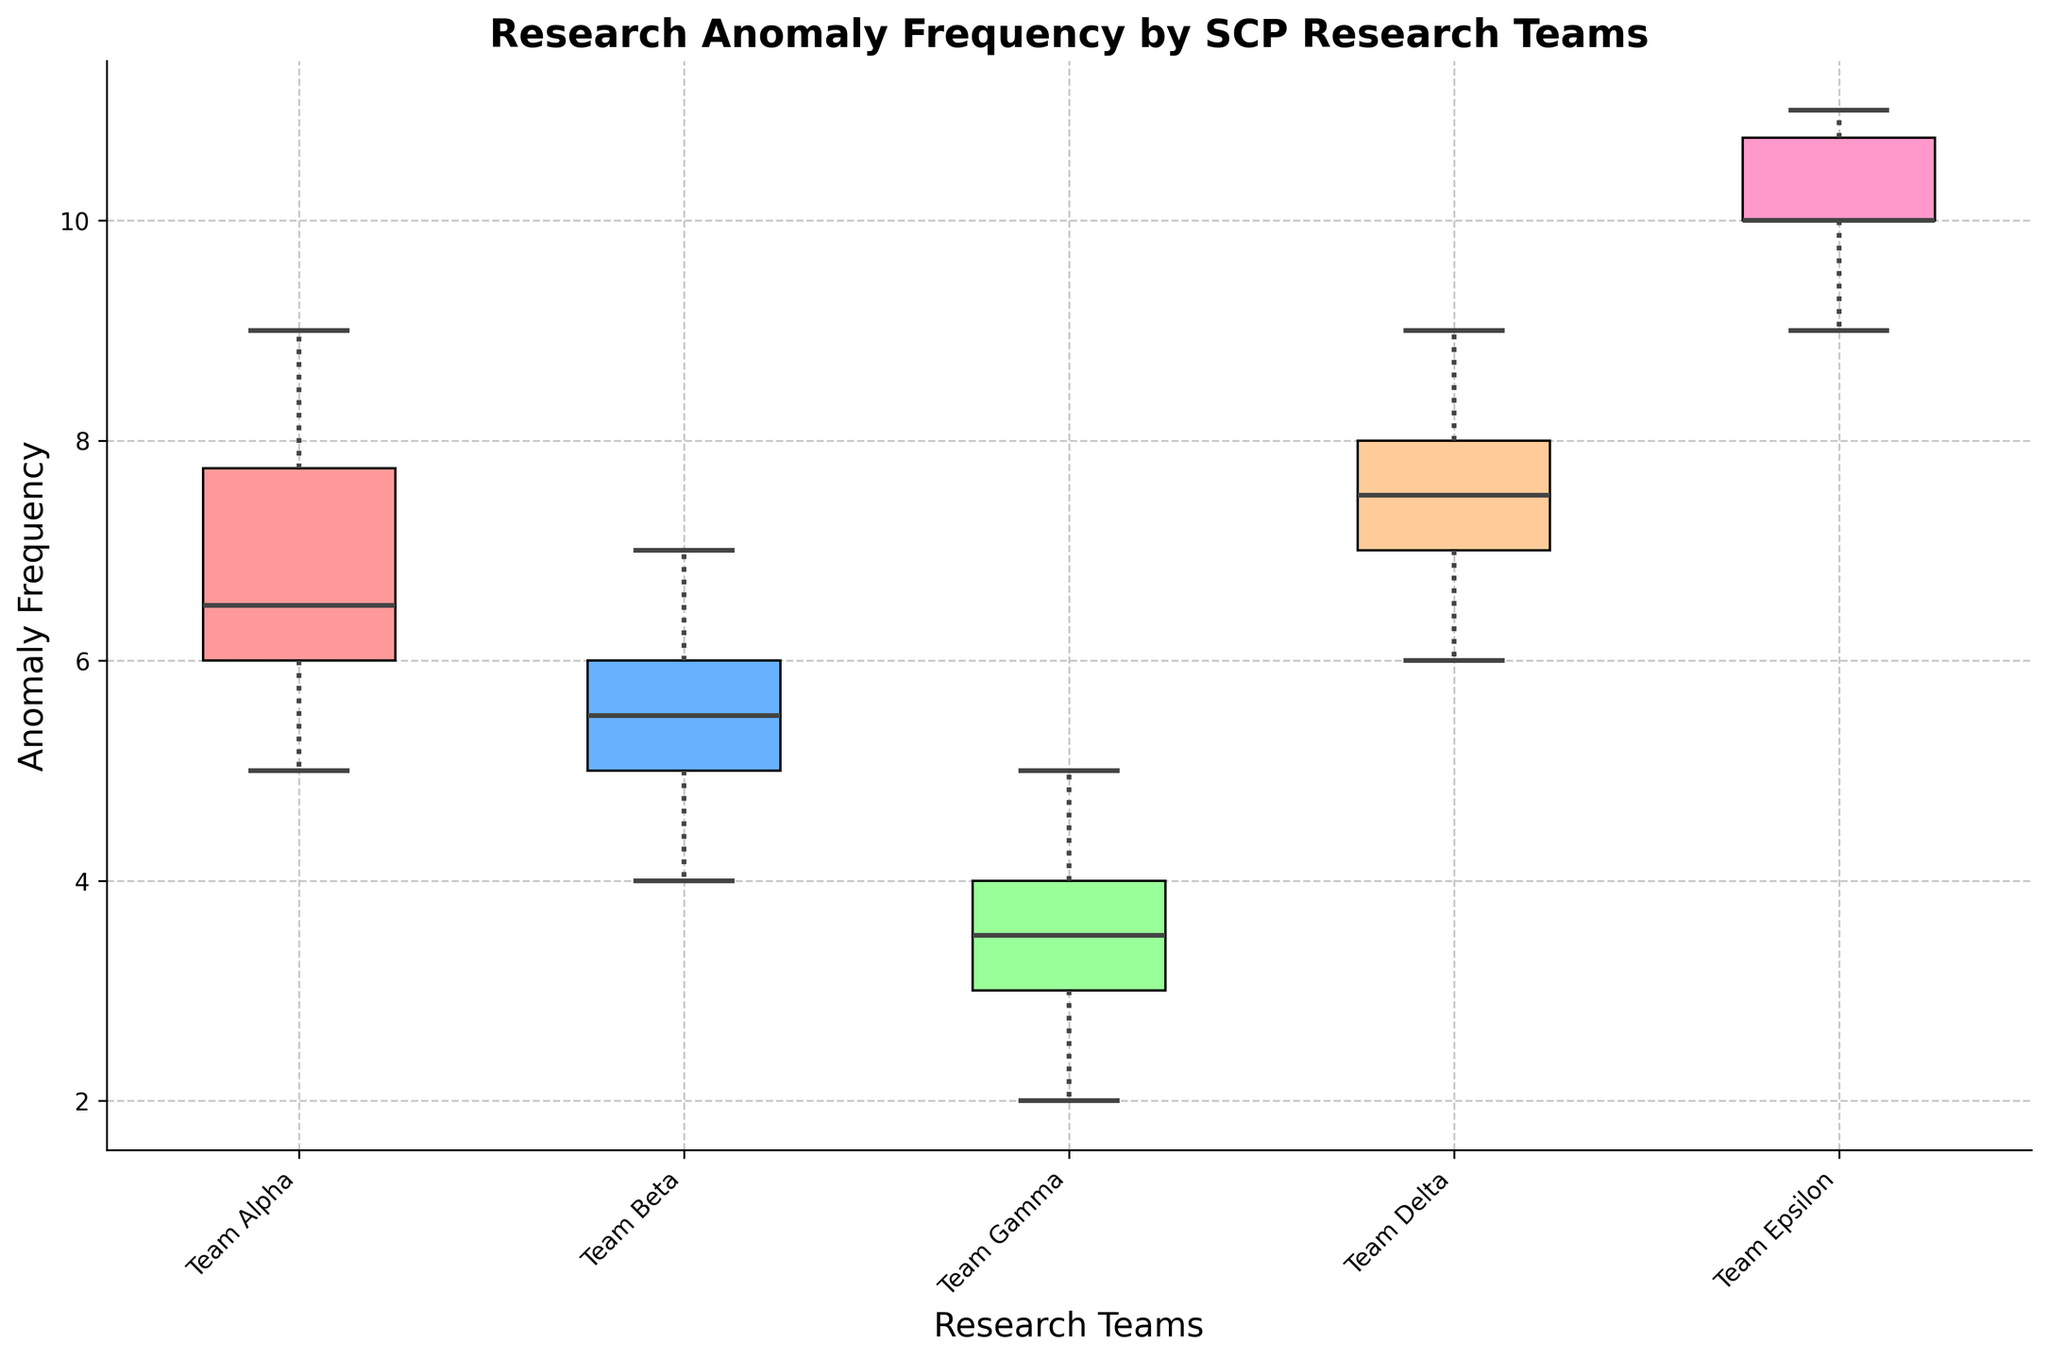What's the title of the figure? The title of the figure is typically located at the top and is set to describe the main focus of the plot. In this case, it is 'Research Anomaly Frequency by SCP Research Teams'.
Answer: Research Anomaly Frequency by SCP Research Teams How many research teams are represented in the figure? The number of unique labels on the x-axis of the box plot represents the number of research teams. The teams listed are Team Alpha, Team Beta, Team Gamma, Team Delta, and Team Epsilon.
Answer: 5 What's the median anomaly frequency for Team Gamma? To find the median anomaly frequency for Team Gamma, locate the box plot for Team Gamma on the x-axis and identify the horizontal line inside the box which represents the median. The median value for Team Gamma is 3.5.
Answer: 3.5 Which research team has the highest median anomaly frequency? Search for the tallest horizontal line within the boxes of each team’s box plot, as the median is the middle line inside each box. Team Epsilon has the highest median anomaly frequency.
Answer: Team Epsilon Which team has the widest range of anomaly frequencies, and what is that range? To determine the team with the widest range, measure the length between the whiskers (minimum and maximum values) for each box plot. Team Epsilon’s whiskers span from 9 to 11, giving a range of 2, which is visually the widest interval in comparison to other teams.
Answer: Team Epsilon, range of 2 Compare the interquartile range (IQR) of Team Alpha and Team Delta. Which one is larger? The IQR is represented by the length of the box itself - the distance between the bottom and top of the box (Q1 and Q3). Team Alpha’s IQR runs from 6 to 8 (IQR = 2), while Team Delta’s runs from 7 to 8 (IQR = 1). Thus, Team Alpha has a larger IQR.
Answer: Team Alpha Which team has the smallest variance in anomaly frequency? The team with the smallest variance will have the least difference between the data points. Team Gamma's plot is the narrowest with a median close to the upper and lower quartiles, indicating the smallest variance.
Answer: Team Gamma Does any team have outliers in their anomaly frequency data? Outliers in a box plot are marked by individual points outside the whiskers. By visually inspecting the plots, we observe no team has markers beyond the whiskers, indicating no visible outliers.
Answer: No Which teams have their median anomaly frequencies below the overall median of all teams? First, find the medians for each team: Alpha (6.5), Beta (5.5), Gamma (3.5), Delta (7.5), Epsilon (10). The overall median is among these medians and can be calculated: 6.5, 5.5, 3.5, 7.5, 10. Sorting gives: 3.5, 5.5, 6.5, 7.5, 10. The overall median value is 6.5; hence, Teams Beta and Gamma are below this.
Answer: Team Beta, Team Gamma 